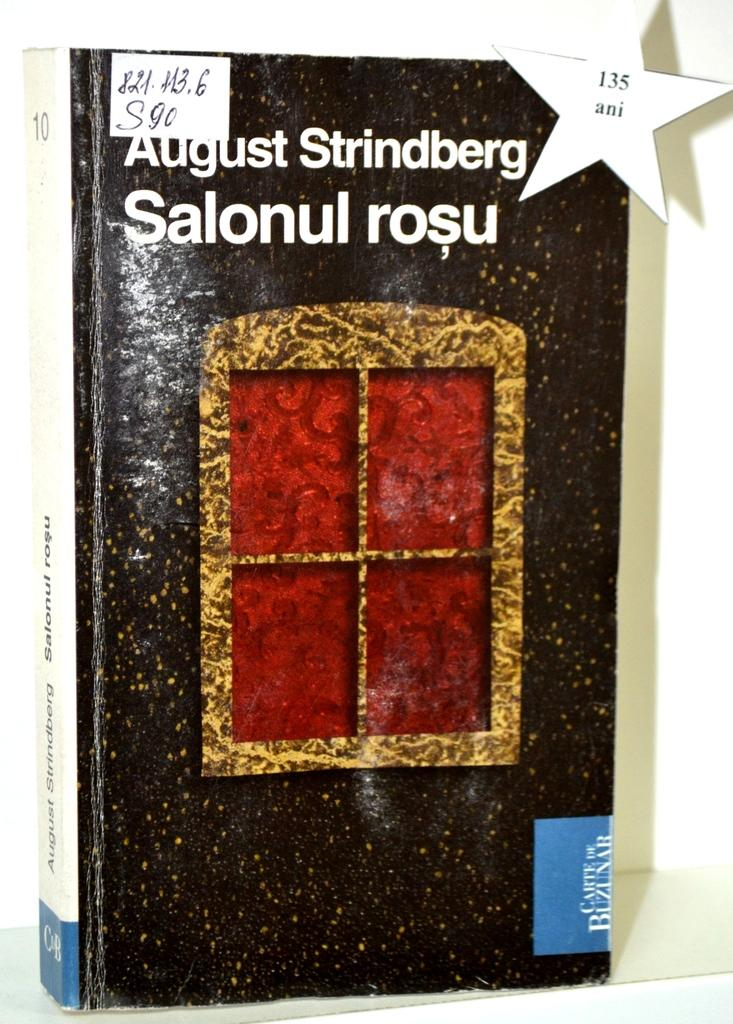<image>
Share a concise interpretation of the image provided. A hardcover copy of Salonul Rose by August Strindberg 